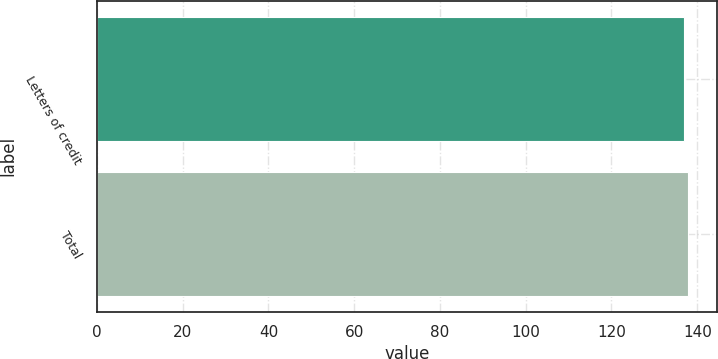Convert chart to OTSL. <chart><loc_0><loc_0><loc_500><loc_500><bar_chart><fcel>Letters of credit<fcel>Total<nl><fcel>136.8<fcel>137.8<nl></chart> 